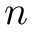<formula> <loc_0><loc_0><loc_500><loc_500>n</formula> 